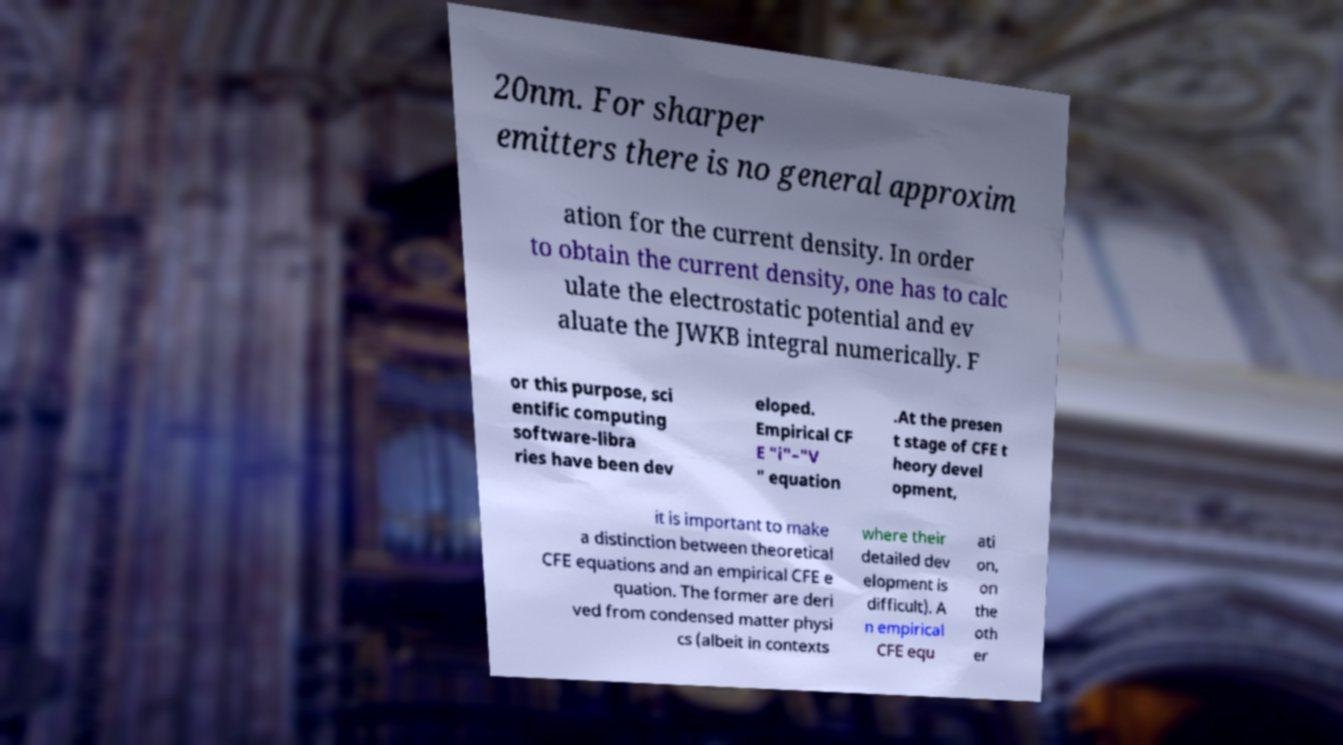For documentation purposes, I need the text within this image transcribed. Could you provide that? 20nm. For sharper emitters there is no general approxim ation for the current density. In order to obtain the current density, one has to calc ulate the electrostatic potential and ev aluate the JWKB integral numerically. F or this purpose, sci entific computing software-libra ries have been dev eloped. Empirical CF E "i"–"V " equation .At the presen t stage of CFE t heory devel opment, it is important to make a distinction between theoretical CFE equations and an empirical CFE e quation. The former are deri ved from condensed matter physi cs (albeit in contexts where their detailed dev elopment is difficult). A n empirical CFE equ ati on, on the oth er 